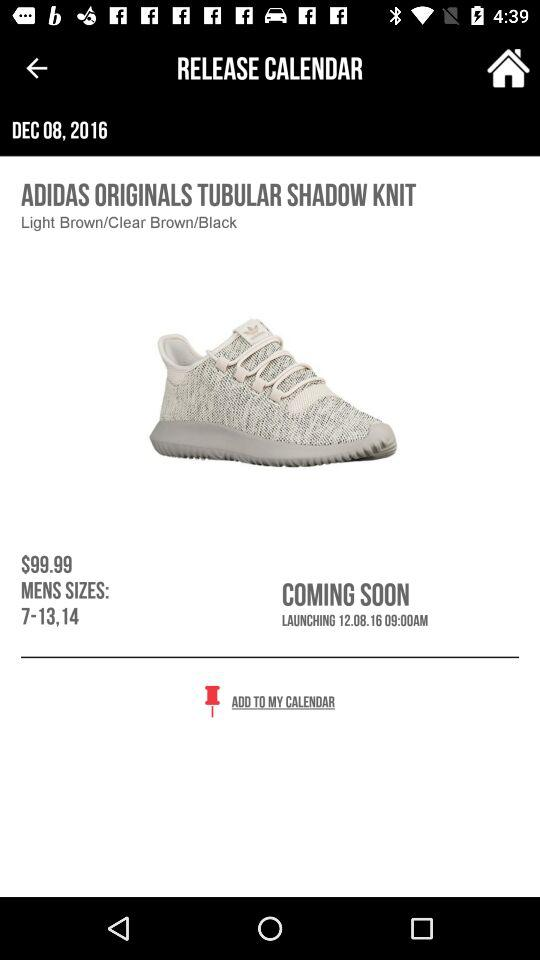How many sizes are available for men's shoes?
When the provided information is insufficient, respond with <no answer>. <no answer> 